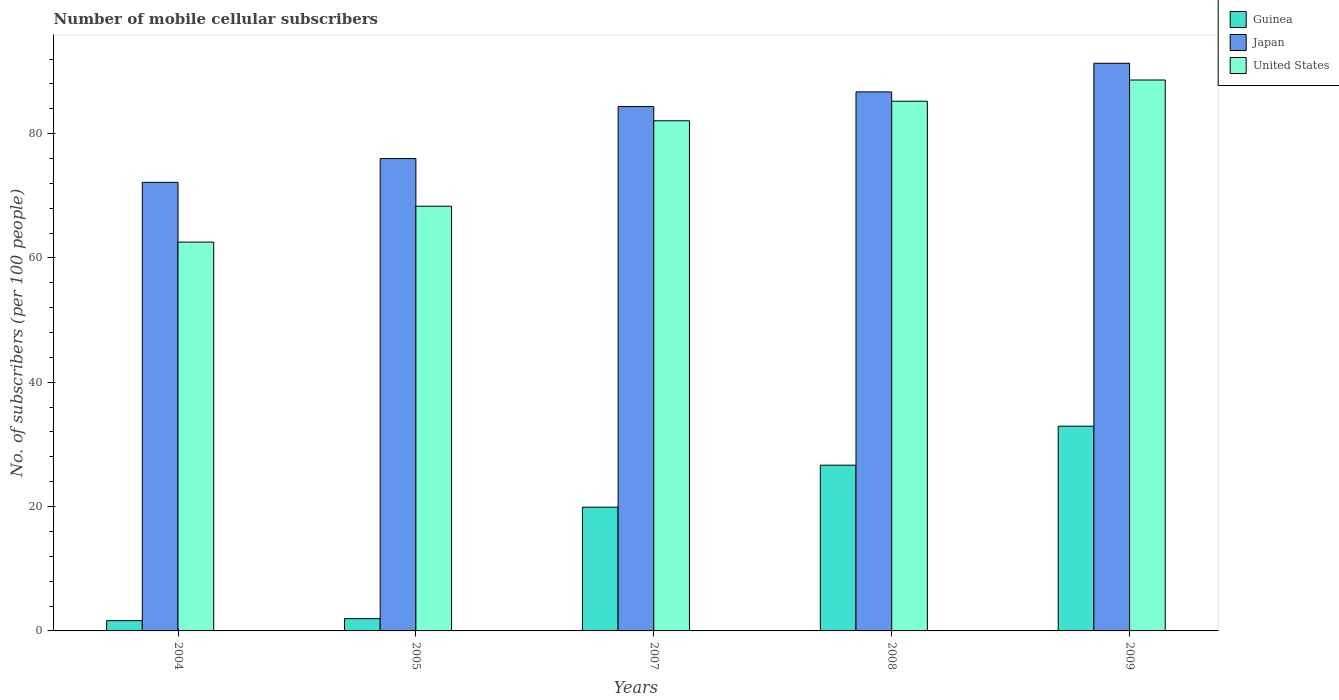Are the number of bars per tick equal to the number of legend labels?
Your response must be concise. Yes. How many bars are there on the 3rd tick from the left?
Provide a short and direct response. 3. In how many cases, is the number of bars for a given year not equal to the number of legend labels?
Offer a very short reply. 0. What is the number of mobile cellular subscribers in United States in 2007?
Provide a short and direct response. 82.06. Across all years, what is the maximum number of mobile cellular subscribers in Guinea?
Your answer should be very brief. 32.94. Across all years, what is the minimum number of mobile cellular subscribers in Guinea?
Provide a short and direct response. 1.65. What is the total number of mobile cellular subscribers in Guinea in the graph?
Your answer should be compact. 83.13. What is the difference between the number of mobile cellular subscribers in Guinea in 2004 and that in 2009?
Offer a terse response. -31.28. What is the difference between the number of mobile cellular subscribers in United States in 2009 and the number of mobile cellular subscribers in Japan in 2004?
Give a very brief answer. 16.47. What is the average number of mobile cellular subscribers in Japan per year?
Provide a short and direct response. 82.1. In the year 2004, what is the difference between the number of mobile cellular subscribers in Guinea and number of mobile cellular subscribers in Japan?
Make the answer very short. -70.5. In how many years, is the number of mobile cellular subscribers in United States greater than 40?
Keep it short and to the point. 5. What is the ratio of the number of mobile cellular subscribers in Guinea in 2007 to that in 2009?
Provide a succinct answer. 0.6. Is the number of mobile cellular subscribers in United States in 2004 less than that in 2009?
Your answer should be very brief. Yes. Is the difference between the number of mobile cellular subscribers in Guinea in 2004 and 2005 greater than the difference between the number of mobile cellular subscribers in Japan in 2004 and 2005?
Keep it short and to the point. Yes. What is the difference between the highest and the second highest number of mobile cellular subscribers in Japan?
Offer a very short reply. 4.61. What is the difference between the highest and the lowest number of mobile cellular subscribers in United States?
Ensure brevity in your answer.  26.08. In how many years, is the number of mobile cellular subscribers in Japan greater than the average number of mobile cellular subscribers in Japan taken over all years?
Your response must be concise. 3. What does the 3rd bar from the left in 2005 represents?
Keep it short and to the point. United States. What does the 1st bar from the right in 2008 represents?
Ensure brevity in your answer.  United States. Is it the case that in every year, the sum of the number of mobile cellular subscribers in United States and number of mobile cellular subscribers in Japan is greater than the number of mobile cellular subscribers in Guinea?
Provide a short and direct response. Yes. How many bars are there?
Offer a terse response. 15. Are all the bars in the graph horizontal?
Ensure brevity in your answer.  No. What is the difference between two consecutive major ticks on the Y-axis?
Keep it short and to the point. 20. Are the values on the major ticks of Y-axis written in scientific E-notation?
Offer a terse response. No. Does the graph contain any zero values?
Your response must be concise. No. Where does the legend appear in the graph?
Keep it short and to the point. Top right. How are the legend labels stacked?
Keep it short and to the point. Vertical. What is the title of the graph?
Offer a terse response. Number of mobile cellular subscribers. Does "Myanmar" appear as one of the legend labels in the graph?
Offer a very short reply. No. What is the label or title of the X-axis?
Offer a terse response. Years. What is the label or title of the Y-axis?
Provide a short and direct response. No. of subscribers (per 100 people). What is the No. of subscribers (per 100 people) of Guinea in 2004?
Provide a short and direct response. 1.65. What is the No. of subscribers (per 100 people) in Japan in 2004?
Give a very brief answer. 72.16. What is the No. of subscribers (per 100 people) of United States in 2004?
Ensure brevity in your answer.  62.55. What is the No. of subscribers (per 100 people) in Guinea in 2005?
Provide a short and direct response. 1.97. What is the No. of subscribers (per 100 people) in Japan in 2005?
Provide a short and direct response. 75.98. What is the No. of subscribers (per 100 people) in United States in 2005?
Make the answer very short. 68.32. What is the No. of subscribers (per 100 people) of Guinea in 2007?
Your response must be concise. 19.91. What is the No. of subscribers (per 100 people) in Japan in 2007?
Keep it short and to the point. 84.35. What is the No. of subscribers (per 100 people) in United States in 2007?
Your answer should be very brief. 82.06. What is the No. of subscribers (per 100 people) of Guinea in 2008?
Your answer should be very brief. 26.66. What is the No. of subscribers (per 100 people) of Japan in 2008?
Offer a terse response. 86.71. What is the No. of subscribers (per 100 people) of United States in 2008?
Keep it short and to the point. 85.21. What is the No. of subscribers (per 100 people) in Guinea in 2009?
Provide a succinct answer. 32.94. What is the No. of subscribers (per 100 people) in Japan in 2009?
Keep it short and to the point. 91.32. What is the No. of subscribers (per 100 people) of United States in 2009?
Keep it short and to the point. 88.62. Across all years, what is the maximum No. of subscribers (per 100 people) in Guinea?
Ensure brevity in your answer.  32.94. Across all years, what is the maximum No. of subscribers (per 100 people) of Japan?
Keep it short and to the point. 91.32. Across all years, what is the maximum No. of subscribers (per 100 people) of United States?
Provide a short and direct response. 88.62. Across all years, what is the minimum No. of subscribers (per 100 people) of Guinea?
Your answer should be compact. 1.65. Across all years, what is the minimum No. of subscribers (per 100 people) of Japan?
Ensure brevity in your answer.  72.16. Across all years, what is the minimum No. of subscribers (per 100 people) of United States?
Your answer should be very brief. 62.55. What is the total No. of subscribers (per 100 people) in Guinea in the graph?
Give a very brief answer. 83.13. What is the total No. of subscribers (per 100 people) of Japan in the graph?
Keep it short and to the point. 410.52. What is the total No. of subscribers (per 100 people) in United States in the graph?
Give a very brief answer. 386.76. What is the difference between the No. of subscribers (per 100 people) in Guinea in 2004 and that in 2005?
Ensure brevity in your answer.  -0.32. What is the difference between the No. of subscribers (per 100 people) of Japan in 2004 and that in 2005?
Your response must be concise. -3.83. What is the difference between the No. of subscribers (per 100 people) in United States in 2004 and that in 2005?
Offer a very short reply. -5.77. What is the difference between the No. of subscribers (per 100 people) in Guinea in 2004 and that in 2007?
Keep it short and to the point. -18.26. What is the difference between the No. of subscribers (per 100 people) of Japan in 2004 and that in 2007?
Keep it short and to the point. -12.2. What is the difference between the No. of subscribers (per 100 people) in United States in 2004 and that in 2007?
Make the answer very short. -19.52. What is the difference between the No. of subscribers (per 100 people) of Guinea in 2004 and that in 2008?
Give a very brief answer. -25.01. What is the difference between the No. of subscribers (per 100 people) in Japan in 2004 and that in 2008?
Your response must be concise. -14.55. What is the difference between the No. of subscribers (per 100 people) of United States in 2004 and that in 2008?
Make the answer very short. -22.66. What is the difference between the No. of subscribers (per 100 people) in Guinea in 2004 and that in 2009?
Keep it short and to the point. -31.28. What is the difference between the No. of subscribers (per 100 people) of Japan in 2004 and that in 2009?
Provide a succinct answer. -19.16. What is the difference between the No. of subscribers (per 100 people) in United States in 2004 and that in 2009?
Offer a very short reply. -26.08. What is the difference between the No. of subscribers (per 100 people) of Guinea in 2005 and that in 2007?
Your response must be concise. -17.93. What is the difference between the No. of subscribers (per 100 people) of Japan in 2005 and that in 2007?
Provide a succinct answer. -8.37. What is the difference between the No. of subscribers (per 100 people) in United States in 2005 and that in 2007?
Give a very brief answer. -13.75. What is the difference between the No. of subscribers (per 100 people) of Guinea in 2005 and that in 2008?
Ensure brevity in your answer.  -24.69. What is the difference between the No. of subscribers (per 100 people) in Japan in 2005 and that in 2008?
Your answer should be compact. -10.72. What is the difference between the No. of subscribers (per 100 people) in United States in 2005 and that in 2008?
Make the answer very short. -16.89. What is the difference between the No. of subscribers (per 100 people) in Guinea in 2005 and that in 2009?
Keep it short and to the point. -30.96. What is the difference between the No. of subscribers (per 100 people) of Japan in 2005 and that in 2009?
Your answer should be compact. -15.33. What is the difference between the No. of subscribers (per 100 people) in United States in 2005 and that in 2009?
Keep it short and to the point. -20.31. What is the difference between the No. of subscribers (per 100 people) in Guinea in 2007 and that in 2008?
Your response must be concise. -6.75. What is the difference between the No. of subscribers (per 100 people) in Japan in 2007 and that in 2008?
Give a very brief answer. -2.35. What is the difference between the No. of subscribers (per 100 people) of United States in 2007 and that in 2008?
Your response must be concise. -3.15. What is the difference between the No. of subscribers (per 100 people) of Guinea in 2007 and that in 2009?
Provide a short and direct response. -13.03. What is the difference between the No. of subscribers (per 100 people) in Japan in 2007 and that in 2009?
Your answer should be compact. -6.96. What is the difference between the No. of subscribers (per 100 people) of United States in 2007 and that in 2009?
Offer a very short reply. -6.56. What is the difference between the No. of subscribers (per 100 people) of Guinea in 2008 and that in 2009?
Provide a succinct answer. -6.28. What is the difference between the No. of subscribers (per 100 people) in Japan in 2008 and that in 2009?
Offer a very short reply. -4.61. What is the difference between the No. of subscribers (per 100 people) in United States in 2008 and that in 2009?
Give a very brief answer. -3.41. What is the difference between the No. of subscribers (per 100 people) in Guinea in 2004 and the No. of subscribers (per 100 people) in Japan in 2005?
Offer a very short reply. -74.33. What is the difference between the No. of subscribers (per 100 people) in Guinea in 2004 and the No. of subscribers (per 100 people) in United States in 2005?
Your response must be concise. -66.67. What is the difference between the No. of subscribers (per 100 people) in Japan in 2004 and the No. of subscribers (per 100 people) in United States in 2005?
Offer a very short reply. 3.84. What is the difference between the No. of subscribers (per 100 people) in Guinea in 2004 and the No. of subscribers (per 100 people) in Japan in 2007?
Give a very brief answer. -82.7. What is the difference between the No. of subscribers (per 100 people) in Guinea in 2004 and the No. of subscribers (per 100 people) in United States in 2007?
Provide a succinct answer. -80.41. What is the difference between the No. of subscribers (per 100 people) in Japan in 2004 and the No. of subscribers (per 100 people) in United States in 2007?
Provide a succinct answer. -9.91. What is the difference between the No. of subscribers (per 100 people) in Guinea in 2004 and the No. of subscribers (per 100 people) in Japan in 2008?
Offer a terse response. -85.06. What is the difference between the No. of subscribers (per 100 people) in Guinea in 2004 and the No. of subscribers (per 100 people) in United States in 2008?
Provide a short and direct response. -83.56. What is the difference between the No. of subscribers (per 100 people) in Japan in 2004 and the No. of subscribers (per 100 people) in United States in 2008?
Give a very brief answer. -13.05. What is the difference between the No. of subscribers (per 100 people) of Guinea in 2004 and the No. of subscribers (per 100 people) of Japan in 2009?
Your response must be concise. -89.67. What is the difference between the No. of subscribers (per 100 people) of Guinea in 2004 and the No. of subscribers (per 100 people) of United States in 2009?
Ensure brevity in your answer.  -86.97. What is the difference between the No. of subscribers (per 100 people) of Japan in 2004 and the No. of subscribers (per 100 people) of United States in 2009?
Your answer should be very brief. -16.47. What is the difference between the No. of subscribers (per 100 people) in Guinea in 2005 and the No. of subscribers (per 100 people) in Japan in 2007?
Keep it short and to the point. -82.38. What is the difference between the No. of subscribers (per 100 people) of Guinea in 2005 and the No. of subscribers (per 100 people) of United States in 2007?
Provide a short and direct response. -80.09. What is the difference between the No. of subscribers (per 100 people) of Japan in 2005 and the No. of subscribers (per 100 people) of United States in 2007?
Provide a short and direct response. -6.08. What is the difference between the No. of subscribers (per 100 people) of Guinea in 2005 and the No. of subscribers (per 100 people) of Japan in 2008?
Provide a short and direct response. -84.73. What is the difference between the No. of subscribers (per 100 people) in Guinea in 2005 and the No. of subscribers (per 100 people) in United States in 2008?
Offer a very short reply. -83.24. What is the difference between the No. of subscribers (per 100 people) in Japan in 2005 and the No. of subscribers (per 100 people) in United States in 2008?
Provide a short and direct response. -9.22. What is the difference between the No. of subscribers (per 100 people) in Guinea in 2005 and the No. of subscribers (per 100 people) in Japan in 2009?
Keep it short and to the point. -89.34. What is the difference between the No. of subscribers (per 100 people) in Guinea in 2005 and the No. of subscribers (per 100 people) in United States in 2009?
Your answer should be compact. -86.65. What is the difference between the No. of subscribers (per 100 people) of Japan in 2005 and the No. of subscribers (per 100 people) of United States in 2009?
Your answer should be compact. -12.64. What is the difference between the No. of subscribers (per 100 people) in Guinea in 2007 and the No. of subscribers (per 100 people) in Japan in 2008?
Keep it short and to the point. -66.8. What is the difference between the No. of subscribers (per 100 people) in Guinea in 2007 and the No. of subscribers (per 100 people) in United States in 2008?
Offer a terse response. -65.3. What is the difference between the No. of subscribers (per 100 people) of Japan in 2007 and the No. of subscribers (per 100 people) of United States in 2008?
Your answer should be very brief. -0.86. What is the difference between the No. of subscribers (per 100 people) of Guinea in 2007 and the No. of subscribers (per 100 people) of Japan in 2009?
Offer a terse response. -71.41. What is the difference between the No. of subscribers (per 100 people) in Guinea in 2007 and the No. of subscribers (per 100 people) in United States in 2009?
Your answer should be very brief. -68.72. What is the difference between the No. of subscribers (per 100 people) of Japan in 2007 and the No. of subscribers (per 100 people) of United States in 2009?
Offer a terse response. -4.27. What is the difference between the No. of subscribers (per 100 people) of Guinea in 2008 and the No. of subscribers (per 100 people) of Japan in 2009?
Make the answer very short. -64.66. What is the difference between the No. of subscribers (per 100 people) of Guinea in 2008 and the No. of subscribers (per 100 people) of United States in 2009?
Your answer should be compact. -61.96. What is the difference between the No. of subscribers (per 100 people) in Japan in 2008 and the No. of subscribers (per 100 people) in United States in 2009?
Your answer should be very brief. -1.92. What is the average No. of subscribers (per 100 people) in Guinea per year?
Make the answer very short. 16.63. What is the average No. of subscribers (per 100 people) of Japan per year?
Give a very brief answer. 82.1. What is the average No. of subscribers (per 100 people) of United States per year?
Your response must be concise. 77.35. In the year 2004, what is the difference between the No. of subscribers (per 100 people) in Guinea and No. of subscribers (per 100 people) in Japan?
Offer a terse response. -70.5. In the year 2004, what is the difference between the No. of subscribers (per 100 people) in Guinea and No. of subscribers (per 100 people) in United States?
Keep it short and to the point. -60.9. In the year 2004, what is the difference between the No. of subscribers (per 100 people) in Japan and No. of subscribers (per 100 people) in United States?
Your answer should be very brief. 9.61. In the year 2005, what is the difference between the No. of subscribers (per 100 people) in Guinea and No. of subscribers (per 100 people) in Japan?
Offer a very short reply. -74.01. In the year 2005, what is the difference between the No. of subscribers (per 100 people) of Guinea and No. of subscribers (per 100 people) of United States?
Provide a short and direct response. -66.34. In the year 2005, what is the difference between the No. of subscribers (per 100 people) in Japan and No. of subscribers (per 100 people) in United States?
Your response must be concise. 7.67. In the year 2007, what is the difference between the No. of subscribers (per 100 people) in Guinea and No. of subscribers (per 100 people) in Japan?
Give a very brief answer. -64.45. In the year 2007, what is the difference between the No. of subscribers (per 100 people) of Guinea and No. of subscribers (per 100 people) of United States?
Provide a short and direct response. -62.16. In the year 2007, what is the difference between the No. of subscribers (per 100 people) of Japan and No. of subscribers (per 100 people) of United States?
Give a very brief answer. 2.29. In the year 2008, what is the difference between the No. of subscribers (per 100 people) of Guinea and No. of subscribers (per 100 people) of Japan?
Your response must be concise. -60.05. In the year 2008, what is the difference between the No. of subscribers (per 100 people) in Guinea and No. of subscribers (per 100 people) in United States?
Make the answer very short. -58.55. In the year 2008, what is the difference between the No. of subscribers (per 100 people) in Japan and No. of subscribers (per 100 people) in United States?
Provide a short and direct response. 1.5. In the year 2009, what is the difference between the No. of subscribers (per 100 people) of Guinea and No. of subscribers (per 100 people) of Japan?
Your answer should be compact. -58.38. In the year 2009, what is the difference between the No. of subscribers (per 100 people) of Guinea and No. of subscribers (per 100 people) of United States?
Your answer should be compact. -55.69. In the year 2009, what is the difference between the No. of subscribers (per 100 people) in Japan and No. of subscribers (per 100 people) in United States?
Your response must be concise. 2.69. What is the ratio of the No. of subscribers (per 100 people) in Guinea in 2004 to that in 2005?
Provide a succinct answer. 0.84. What is the ratio of the No. of subscribers (per 100 people) of Japan in 2004 to that in 2005?
Give a very brief answer. 0.95. What is the ratio of the No. of subscribers (per 100 people) in United States in 2004 to that in 2005?
Make the answer very short. 0.92. What is the ratio of the No. of subscribers (per 100 people) of Guinea in 2004 to that in 2007?
Your answer should be compact. 0.08. What is the ratio of the No. of subscribers (per 100 people) of Japan in 2004 to that in 2007?
Provide a short and direct response. 0.86. What is the ratio of the No. of subscribers (per 100 people) of United States in 2004 to that in 2007?
Give a very brief answer. 0.76. What is the ratio of the No. of subscribers (per 100 people) of Guinea in 2004 to that in 2008?
Provide a succinct answer. 0.06. What is the ratio of the No. of subscribers (per 100 people) in Japan in 2004 to that in 2008?
Your response must be concise. 0.83. What is the ratio of the No. of subscribers (per 100 people) in United States in 2004 to that in 2008?
Your answer should be compact. 0.73. What is the ratio of the No. of subscribers (per 100 people) of Guinea in 2004 to that in 2009?
Offer a terse response. 0.05. What is the ratio of the No. of subscribers (per 100 people) in Japan in 2004 to that in 2009?
Give a very brief answer. 0.79. What is the ratio of the No. of subscribers (per 100 people) of United States in 2004 to that in 2009?
Ensure brevity in your answer.  0.71. What is the ratio of the No. of subscribers (per 100 people) in Guinea in 2005 to that in 2007?
Your answer should be compact. 0.1. What is the ratio of the No. of subscribers (per 100 people) in Japan in 2005 to that in 2007?
Give a very brief answer. 0.9. What is the ratio of the No. of subscribers (per 100 people) of United States in 2005 to that in 2007?
Provide a succinct answer. 0.83. What is the ratio of the No. of subscribers (per 100 people) of Guinea in 2005 to that in 2008?
Your answer should be very brief. 0.07. What is the ratio of the No. of subscribers (per 100 people) in Japan in 2005 to that in 2008?
Provide a short and direct response. 0.88. What is the ratio of the No. of subscribers (per 100 people) in United States in 2005 to that in 2008?
Keep it short and to the point. 0.8. What is the ratio of the No. of subscribers (per 100 people) in Guinea in 2005 to that in 2009?
Make the answer very short. 0.06. What is the ratio of the No. of subscribers (per 100 people) in Japan in 2005 to that in 2009?
Offer a very short reply. 0.83. What is the ratio of the No. of subscribers (per 100 people) of United States in 2005 to that in 2009?
Your response must be concise. 0.77. What is the ratio of the No. of subscribers (per 100 people) of Guinea in 2007 to that in 2008?
Make the answer very short. 0.75. What is the ratio of the No. of subscribers (per 100 people) in Japan in 2007 to that in 2008?
Offer a very short reply. 0.97. What is the ratio of the No. of subscribers (per 100 people) of United States in 2007 to that in 2008?
Offer a very short reply. 0.96. What is the ratio of the No. of subscribers (per 100 people) of Guinea in 2007 to that in 2009?
Offer a terse response. 0.6. What is the ratio of the No. of subscribers (per 100 people) in Japan in 2007 to that in 2009?
Provide a short and direct response. 0.92. What is the ratio of the No. of subscribers (per 100 people) of United States in 2007 to that in 2009?
Your answer should be very brief. 0.93. What is the ratio of the No. of subscribers (per 100 people) of Guinea in 2008 to that in 2009?
Make the answer very short. 0.81. What is the ratio of the No. of subscribers (per 100 people) of Japan in 2008 to that in 2009?
Offer a very short reply. 0.95. What is the ratio of the No. of subscribers (per 100 people) of United States in 2008 to that in 2009?
Your answer should be compact. 0.96. What is the difference between the highest and the second highest No. of subscribers (per 100 people) in Guinea?
Ensure brevity in your answer.  6.28. What is the difference between the highest and the second highest No. of subscribers (per 100 people) of Japan?
Give a very brief answer. 4.61. What is the difference between the highest and the second highest No. of subscribers (per 100 people) in United States?
Offer a terse response. 3.41. What is the difference between the highest and the lowest No. of subscribers (per 100 people) of Guinea?
Offer a very short reply. 31.28. What is the difference between the highest and the lowest No. of subscribers (per 100 people) in Japan?
Offer a very short reply. 19.16. What is the difference between the highest and the lowest No. of subscribers (per 100 people) of United States?
Keep it short and to the point. 26.08. 